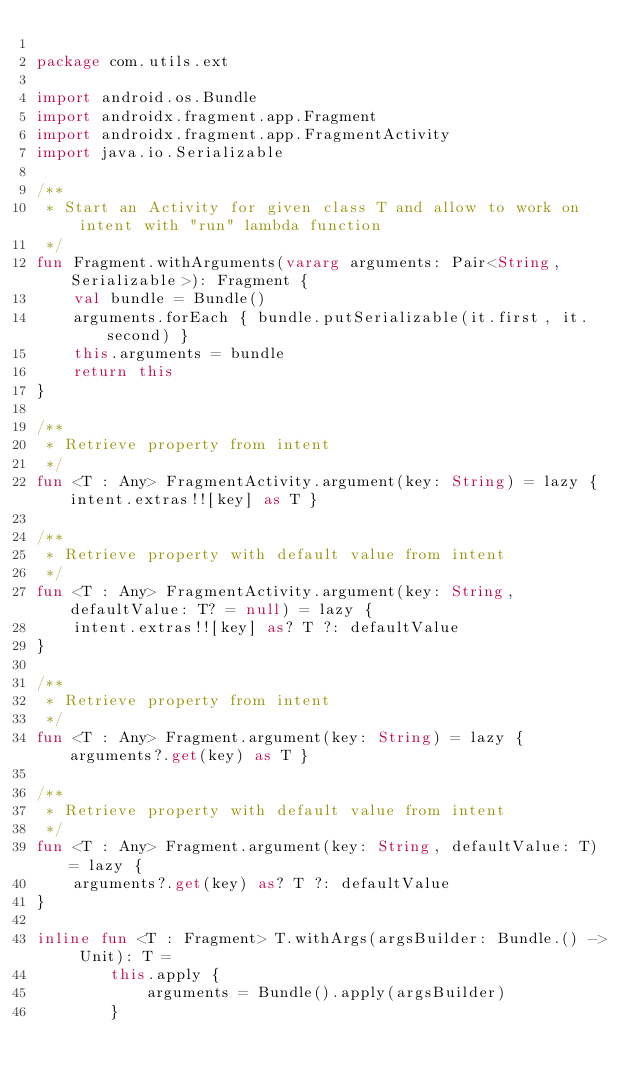Convert code to text. <code><loc_0><loc_0><loc_500><loc_500><_Kotlin_>
package com.utils.ext

import android.os.Bundle
import androidx.fragment.app.Fragment
import androidx.fragment.app.FragmentActivity
import java.io.Serializable

/**
 * Start an Activity for given class T and allow to work on intent with "run" lambda function
 */
fun Fragment.withArguments(vararg arguments: Pair<String, Serializable>): Fragment {
    val bundle = Bundle()
    arguments.forEach { bundle.putSerializable(it.first, it.second) }
    this.arguments = bundle
    return this
}

/**
 * Retrieve property from intent
 */
fun <T : Any> FragmentActivity.argument(key: String) = lazy { intent.extras!![key] as T }

/**
 * Retrieve property with default value from intent
 */
fun <T : Any> FragmentActivity.argument(key: String, defaultValue: T? = null) = lazy {
    intent.extras!![key] as? T ?: defaultValue
}

/**
 * Retrieve property from intent
 */
fun <T : Any> Fragment.argument(key: String) = lazy { arguments?.get(key) as T }

/**
 * Retrieve property with default value from intent
 */
fun <T : Any> Fragment.argument(key: String, defaultValue: T) = lazy {
    arguments?.get(key) as? T ?: defaultValue
}

inline fun <T : Fragment> T.withArgs(argsBuilder: Bundle.() -> Unit): T =
        this.apply {
            arguments = Bundle().apply(argsBuilder)
        }</code> 